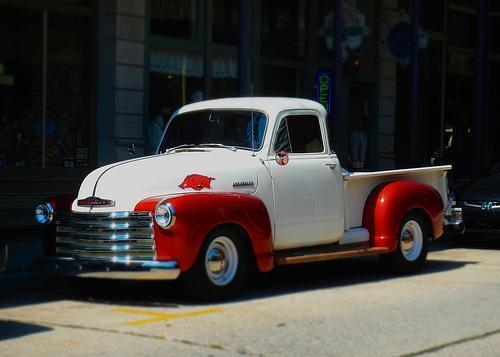How many cars are there?
Give a very brief answer. 1. 